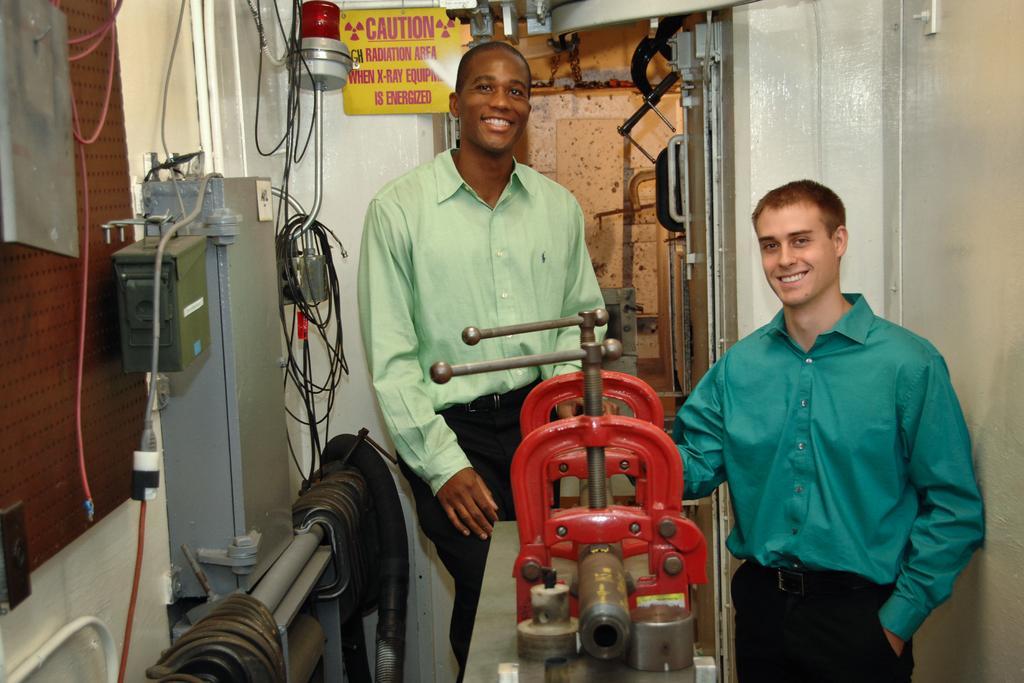Could you give a brief overview of what you see in this image? In this image I can see two people standing in the machine room. There are some machines and wires and some boards in this image.  